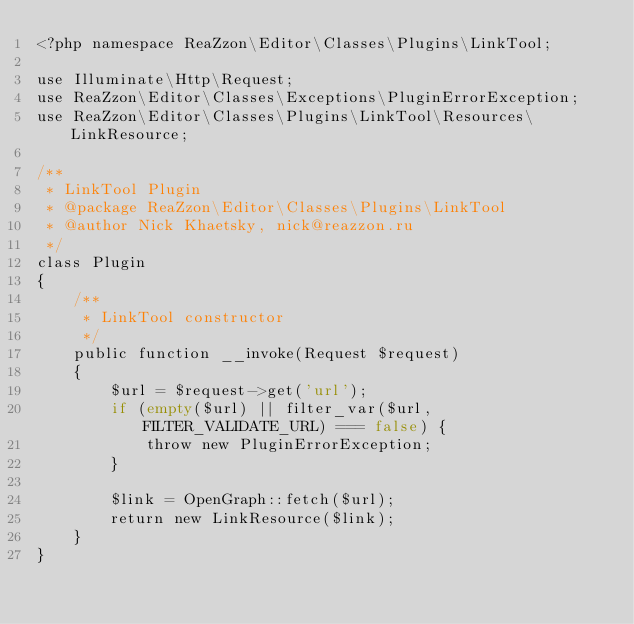<code> <loc_0><loc_0><loc_500><loc_500><_PHP_><?php namespace ReaZzon\Editor\Classes\Plugins\LinkTool;

use Illuminate\Http\Request;
use ReaZzon\Editor\Classes\Exceptions\PluginErrorException;
use ReaZzon\Editor\Classes\Plugins\LinkTool\Resources\LinkResource;

/**
 * LinkTool Plugin
 * @package ReaZzon\Editor\Classes\Plugins\LinkTool
 * @author Nick Khaetsky, nick@reazzon.ru
 */
class Plugin
{
    /**
     * LinkTool constructor
     */
    public function __invoke(Request $request)
    {
        $url = $request->get('url');
        if (empty($url) || filter_var($url, FILTER_VALIDATE_URL) === false) {
            throw new PluginErrorException;
        }

        $link = OpenGraph::fetch($url);
        return new LinkResource($link);
    }
}
</code> 